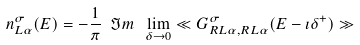<formula> <loc_0><loc_0><loc_500><loc_500>n ^ { \sigma } _ { L \alpha } ( E ) = - \frac { 1 } { \pi } \ \Im m \ \lim _ { \delta \rightarrow 0 } \ll G ^ { \sigma } _ { R L \alpha , R L \alpha } ( E - \imath \delta ^ { + } ) \gg</formula> 